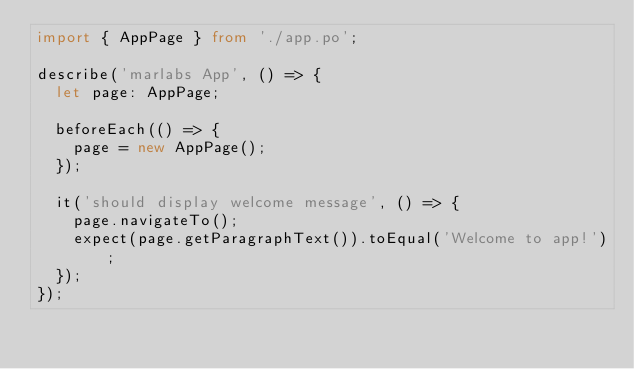Convert code to text. <code><loc_0><loc_0><loc_500><loc_500><_TypeScript_>import { AppPage } from './app.po';

describe('marlabs App', () => {
  let page: AppPage;

  beforeEach(() => {
    page = new AppPage();
  });

  it('should display welcome message', () => {
    page.navigateTo();
    expect(page.getParagraphText()).toEqual('Welcome to app!');
  });
});
</code> 